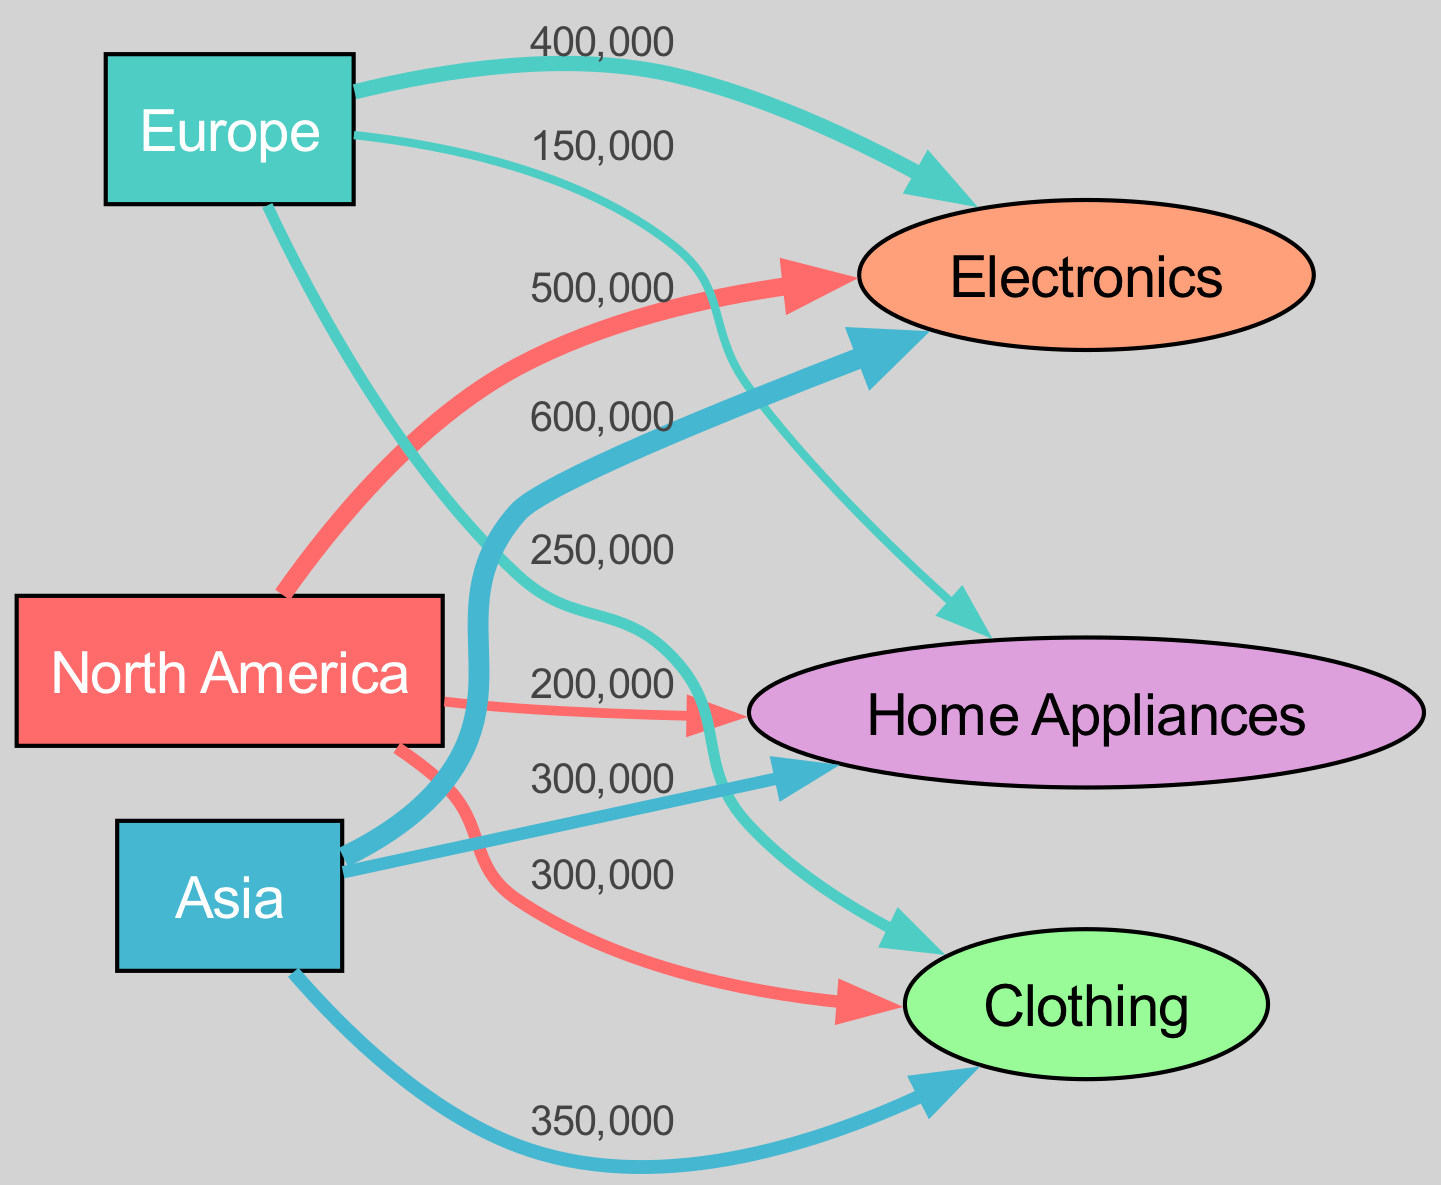What is the total sales value for the Electronics product in North America? In the diagram, we look for the link between North America and Electronics. The value of this link is explicitly stated as 500,000.
Answer: 500,000 What is the highest sales value among product lines in Europe? We compare the sales values for each product line in Europe: Electronics is 400,000, Clothing is 250,000, and Home Appliances is 150,000. The highest value is 400,000, which corresponds to Electronics.
Answer: 400,000 How many product lines are represented in the diagram? The diagram lists three product lines: Electronics, Clothing, and Home Appliances. We can count these nodes to find that there are three product lines.
Answer: 3 Which geographic region has the lowest sales for Clothing? By checking the links for Clothing, we see North America with 300,000, Europe with 250,000, and Asia with 350,000. The lowest sales value is for Europe at 250,000.
Answer: Europe What is the total sales value for Home Appliances across all regions? We examine the links for Home Appliances: 200,000 from North America, 150,000 from Europe, and 300,000 from Asia. By summing these values: 200,000 + 150,000 + 300,000 equals 650,000.
Answer: 650,000 Which region generates the highest sales value overall? To find the overall highest sales region, we sum the sales for each region. North America has 1,000,000 (500,000 + 300,000 + 200,000), Europe has 800,000 (400,000 + 250,000 + 150,000), and Asia has 1,250,000 (600,000 + 350,000 + 300,000). The highest is for Asia at 1,250,000.
Answer: Asia What is the total sales value for all regions in the Electronics product line? The values for Electronics in each region are: 500,000 (North America), 400,000 (Europe), and 600,000 (Asia). Summing these gives us 500,000 + 400,000 + 600,000 equals 1,500,000.
Answer: 1,500,000 What is the relationship between Home Appliances and North America? We look for the specific link that connects Home Appliances to North America in the diagram. The link shows that North America has a sales value of 200,000 for Home Appliances.
Answer: 200,000 Which product line contributes the most to sales in Asia? From the links corresponding to Asia, we see Electronics at 600,000, Clothing at 350,000, and Home Appliances at 300,000. The highest contributor is Electronics at 600,000.
Answer: Electronics 